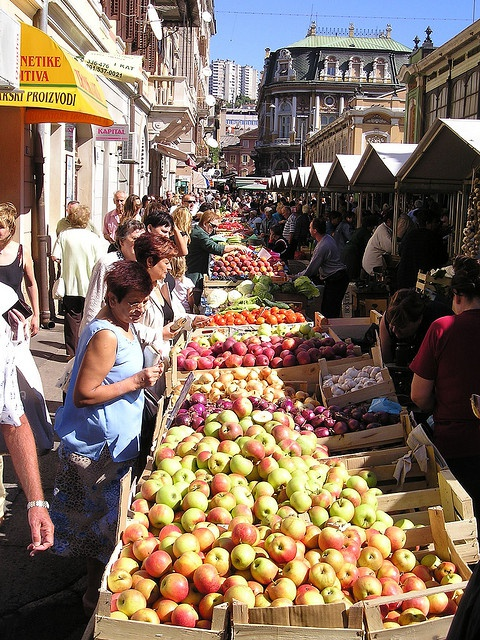Describe the objects in this image and their specific colors. I can see apple in ivory, khaki, orange, and lightyellow tones, people in ivory, black, white, navy, and maroon tones, people in beige, black, maroon, brown, and gray tones, people in ivory, black, white, and gray tones, and people in ivory, white, black, salmon, and brown tones in this image. 